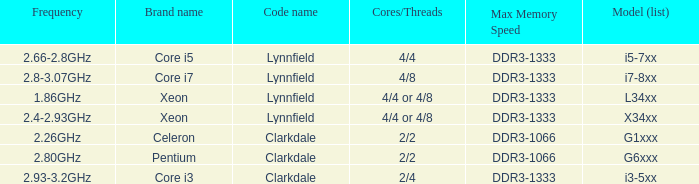I'm looking to parse the entire table for insights. Could you assist me with that? {'header': ['Frequency', 'Brand name', 'Code name', 'Cores/Threads', 'Max Memory Speed', 'Model (list)'], 'rows': [['2.66-2.8GHz', 'Core i5', 'Lynnfield', '4/4', 'DDR3-1333', 'i5-7xx'], ['2.8-3.07GHz', 'Core i7', 'Lynnfield', '4/8', 'DDR3-1333', 'i7-8xx'], ['1.86GHz', 'Xeon', 'Lynnfield', '4/4 or 4/8', 'DDR3-1333', 'L34xx'], ['2.4-2.93GHz', 'Xeon', 'Lynnfield', '4/4 or 4/8', 'DDR3-1333', 'X34xx'], ['2.26GHz', 'Celeron', 'Clarkdale', '2/2', 'DDR3-1066', 'G1xxx'], ['2.80GHz', 'Pentium', 'Clarkdale', '2/2', 'DDR3-1066', 'G6xxx'], ['2.93-3.2GHz', 'Core i3', 'Clarkdale', '2/4', 'DDR3-1333', 'i3-5xx']]} What frequency does model L34xx use? 1.86GHz. 